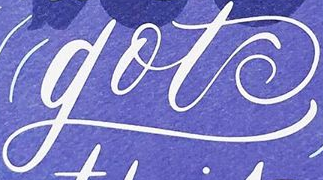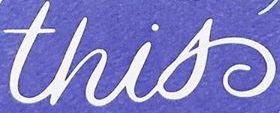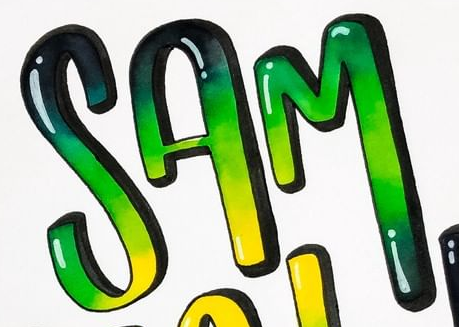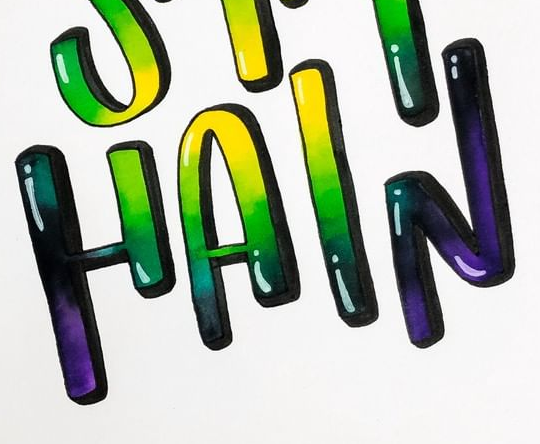What text appears in these images from left to right, separated by a semicolon? got; this; SAM; HAIN 